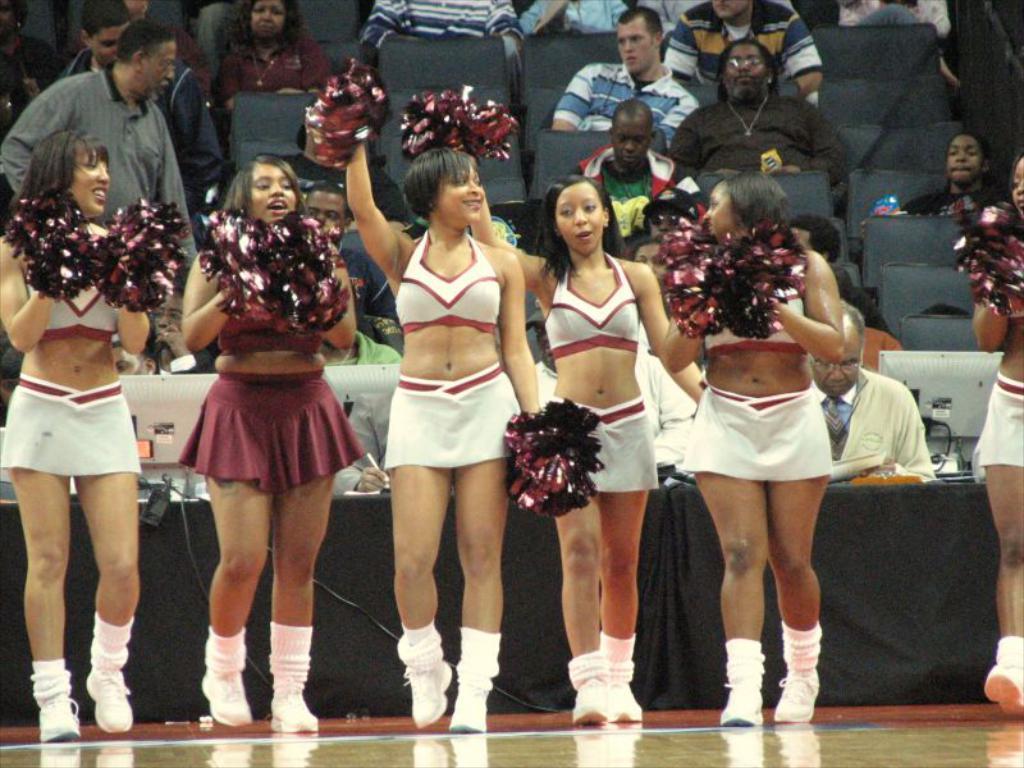Please provide a concise description of this image. In this picture I can observe some women standing on the floor. They are wearing white and maroon color dresses. In the background there are some people sitting in the chairs. 